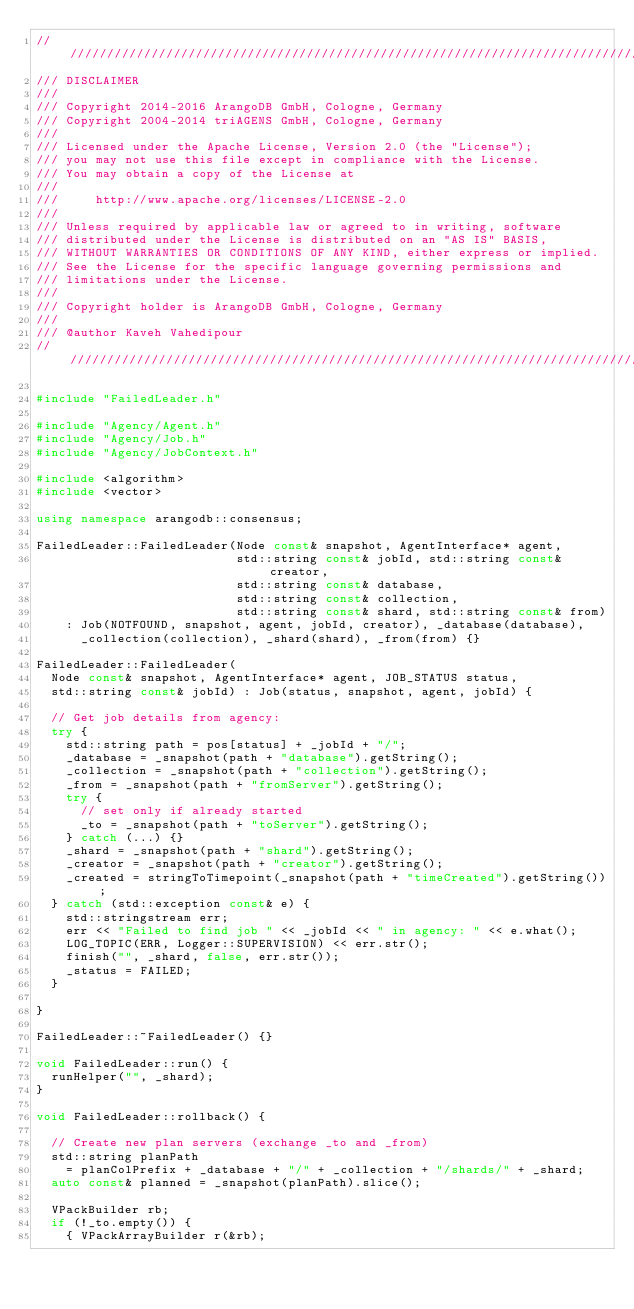<code> <loc_0><loc_0><loc_500><loc_500><_C++_>////////////////////////////////////////////////////////////////////////////////
/// DISCLAIMER
///
/// Copyright 2014-2016 ArangoDB GmbH, Cologne, Germany
/// Copyright 2004-2014 triAGENS GmbH, Cologne, Germany
///
/// Licensed under the Apache License, Version 2.0 (the "License");
/// you may not use this file except in compliance with the License.
/// You may obtain a copy of the License at
///
///     http://www.apache.org/licenses/LICENSE-2.0
///
/// Unless required by applicable law or agreed to in writing, software
/// distributed under the License is distributed on an "AS IS" BASIS,
/// WITHOUT WARRANTIES OR CONDITIONS OF ANY KIND, either express or implied.
/// See the License for the specific language governing permissions and
/// limitations under the License.
///
/// Copyright holder is ArangoDB GmbH, Cologne, Germany
///
/// @author Kaveh Vahedipour
////////////////////////////////////////////////////////////////////////////////

#include "FailedLeader.h"

#include "Agency/Agent.h"
#include "Agency/Job.h"
#include "Agency/JobContext.h"

#include <algorithm>
#include <vector>

using namespace arangodb::consensus;

FailedLeader::FailedLeader(Node const& snapshot, AgentInterface* agent,
                           std::string const& jobId, std::string const& creator,
                           std::string const& database,
                           std::string const& collection,
                           std::string const& shard, std::string const& from)
    : Job(NOTFOUND, snapshot, agent, jobId, creator), _database(database),
      _collection(collection), _shard(shard), _from(from) {}

FailedLeader::FailedLeader(
  Node const& snapshot, AgentInterface* agent, JOB_STATUS status,
  std::string const& jobId) : Job(status, snapshot, agent, jobId) {
  
  // Get job details from agency:
  try {
    std::string path = pos[status] + _jobId + "/";
    _database = _snapshot(path + "database").getString();
    _collection = _snapshot(path + "collection").getString();
    _from = _snapshot(path + "fromServer").getString();
    try {
      // set only if already started
      _to = _snapshot(path + "toServer").getString();
    } catch (...) {}
    _shard = _snapshot(path + "shard").getString();
    _creator = _snapshot(path + "creator").getString();
    _created = stringToTimepoint(_snapshot(path + "timeCreated").getString());
  } catch (std::exception const& e) {
    std::stringstream err;
    err << "Failed to find job " << _jobId << " in agency: " << e.what();
    LOG_TOPIC(ERR, Logger::SUPERVISION) << err.str();
    finish("", _shard, false, err.str());
    _status = FAILED;
  }
  
}

FailedLeader::~FailedLeader() {}

void FailedLeader::run() {
  runHelper("", _shard);
}

void FailedLeader::rollback() {

  // Create new plan servers (exchange _to and _from)
  std::string planPath
    = planColPrefix + _database + "/" + _collection + "/shards/" + _shard;
  auto const& planned = _snapshot(planPath).slice();

  VPackBuilder rb;
  if (!_to.empty()) {
    { VPackArrayBuilder r(&rb);</code> 